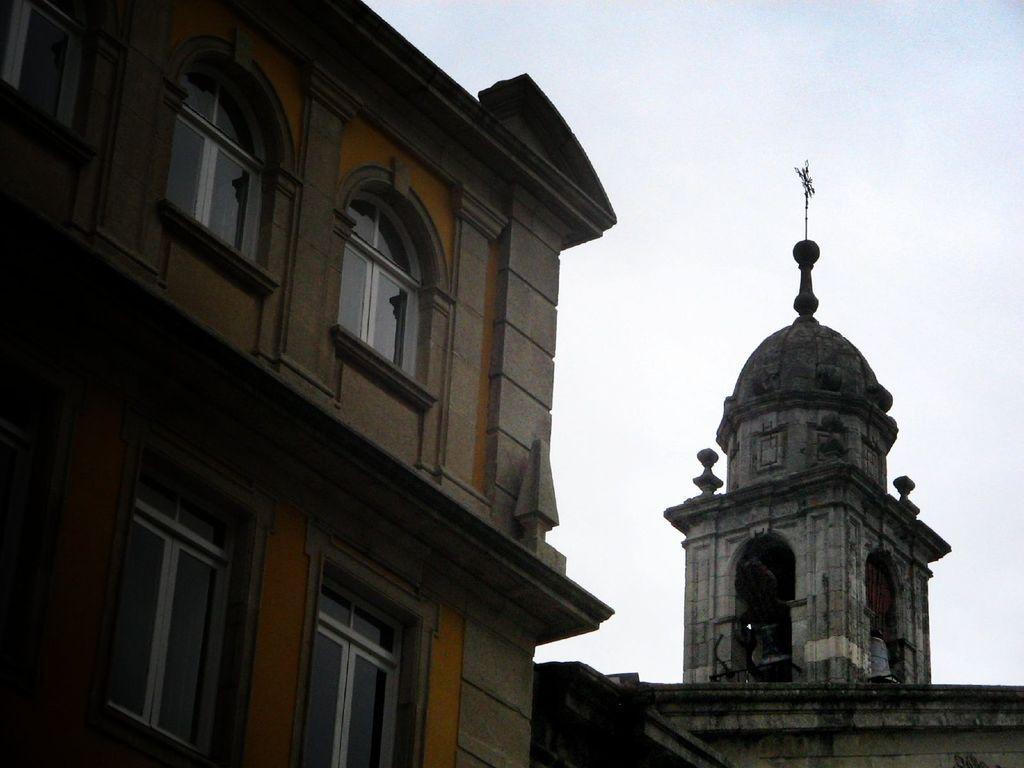How would you summarize this image in a sentence or two? This picture is clicked outside. On the right there is a dome attached to the building. On the left we can see a building and the windows of a building. In the background there is a sky. 